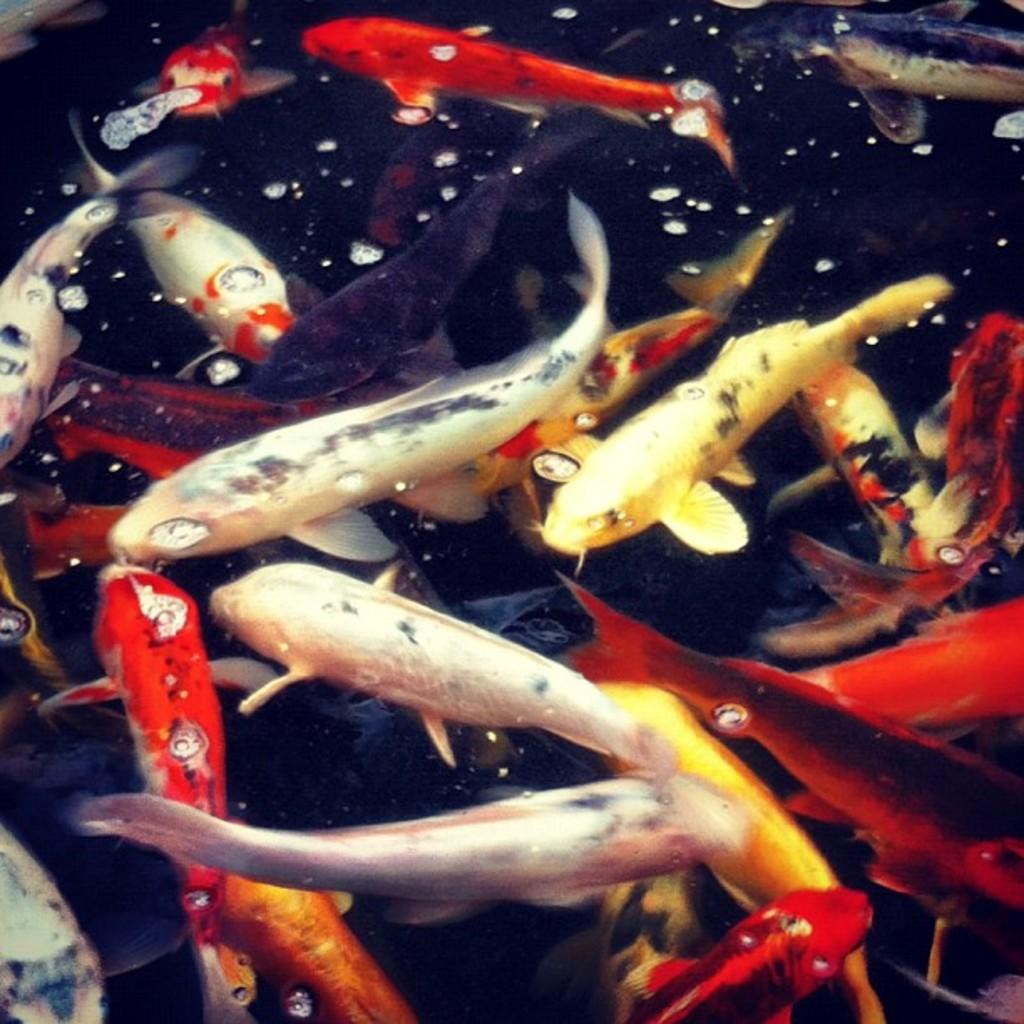What type of animals can be seen in the image? There are fishes in the image. Where are the fishes located? The fishes are in the water. What type of map is visible in the image? There is no map present in the image; it features fishes in the water. What type of soda is being consumed by the fishes in the image? There is no soda present in the image; it features fishes in the water. 